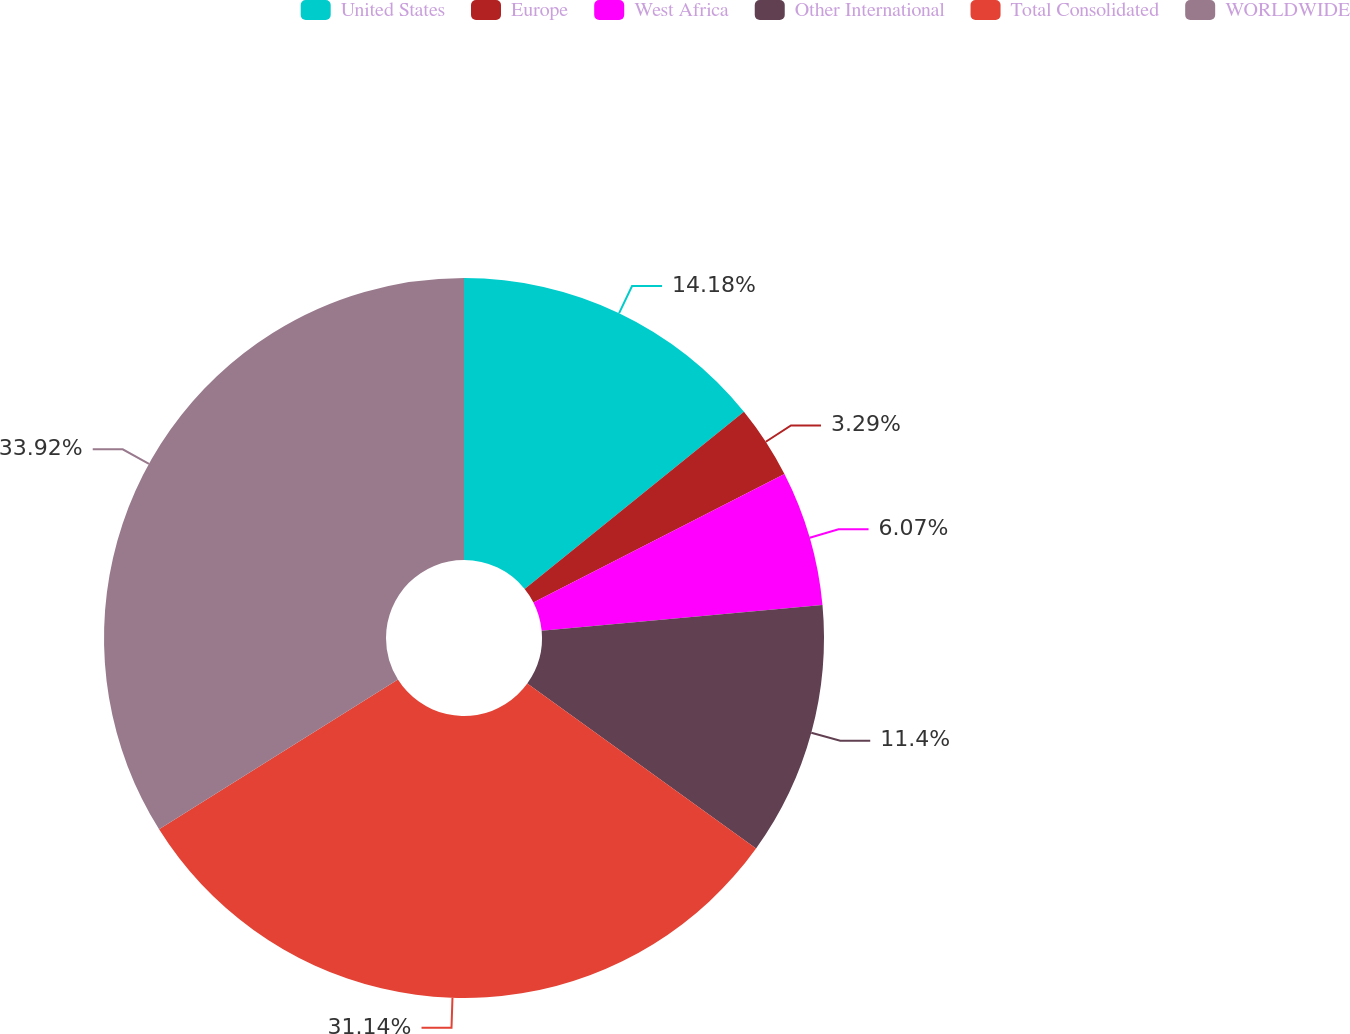Convert chart. <chart><loc_0><loc_0><loc_500><loc_500><pie_chart><fcel>United States<fcel>Europe<fcel>West Africa<fcel>Other International<fcel>Total Consolidated<fcel>WORLDWIDE<nl><fcel>14.18%<fcel>3.29%<fcel>6.07%<fcel>11.4%<fcel>31.14%<fcel>33.92%<nl></chart> 